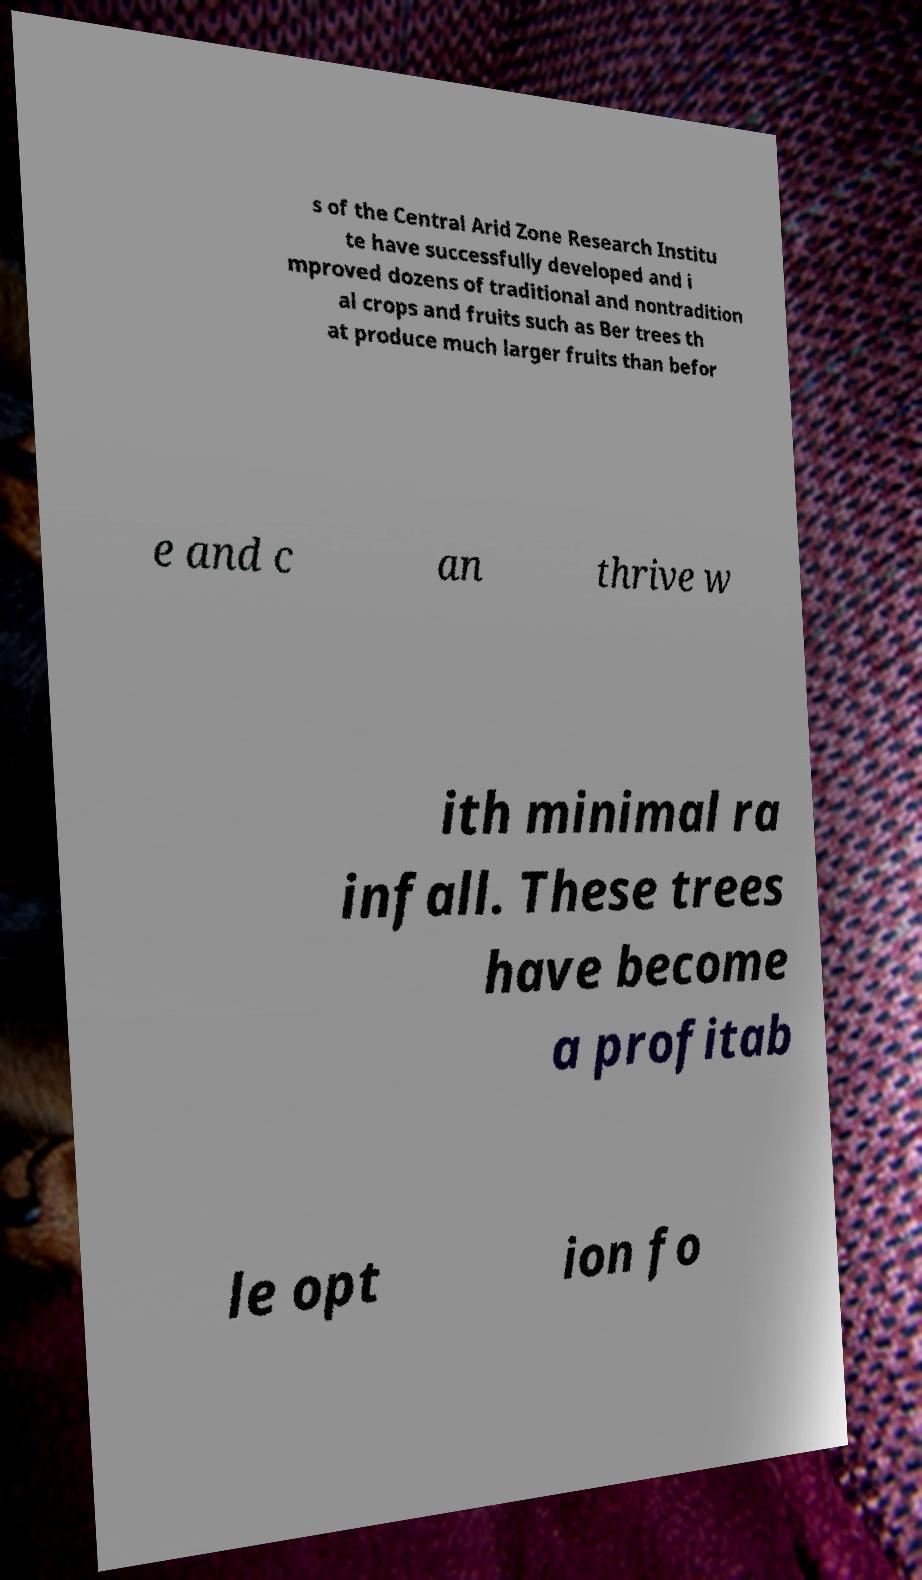Can you accurately transcribe the text from the provided image for me? s of the Central Arid Zone Research Institu te have successfully developed and i mproved dozens of traditional and nontradition al crops and fruits such as Ber trees th at produce much larger fruits than befor e and c an thrive w ith minimal ra infall. These trees have become a profitab le opt ion fo 